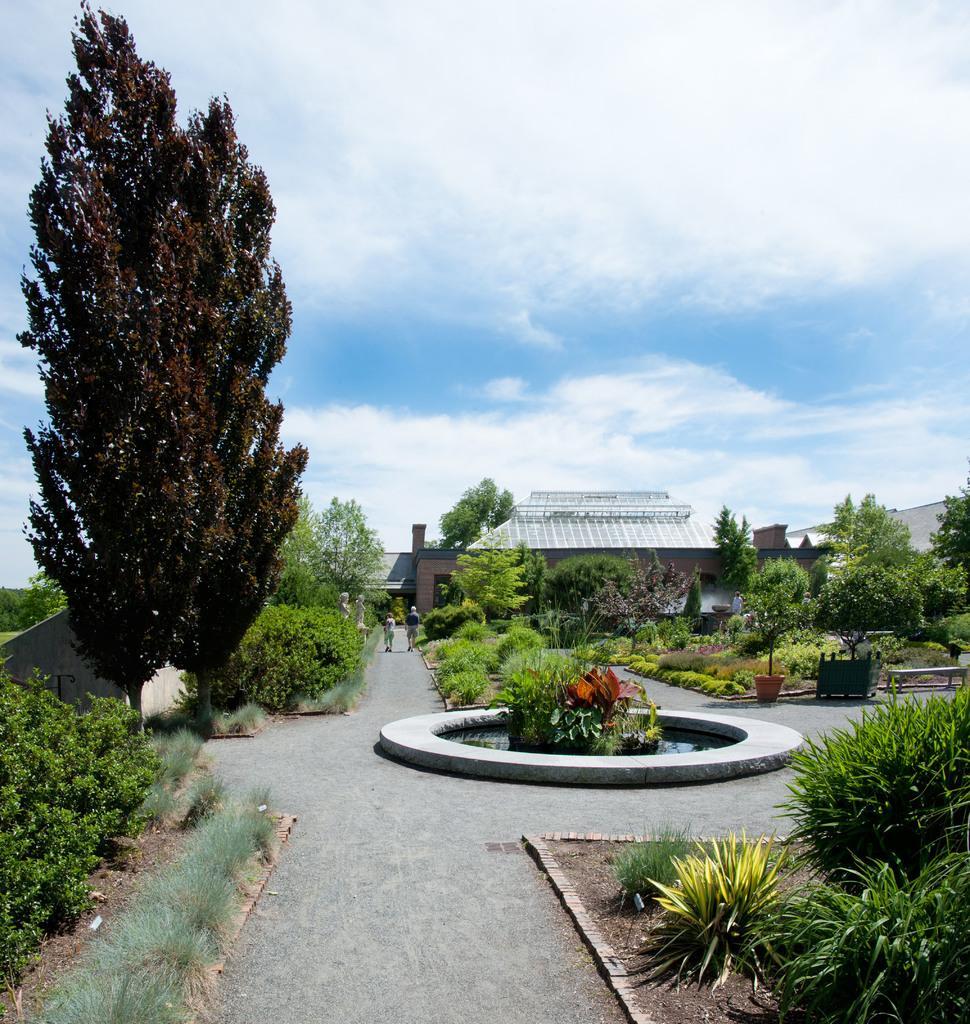Please provide a concise description of this image. In this image, there are trees and bushes. At the center of the image, It looks like a pond. I can see a building behind the trees. In the background, there is the sky. There are two people walking on the pathway. On the right side of the image, I can see a bench, wooden object and a flower pot with a plant. 